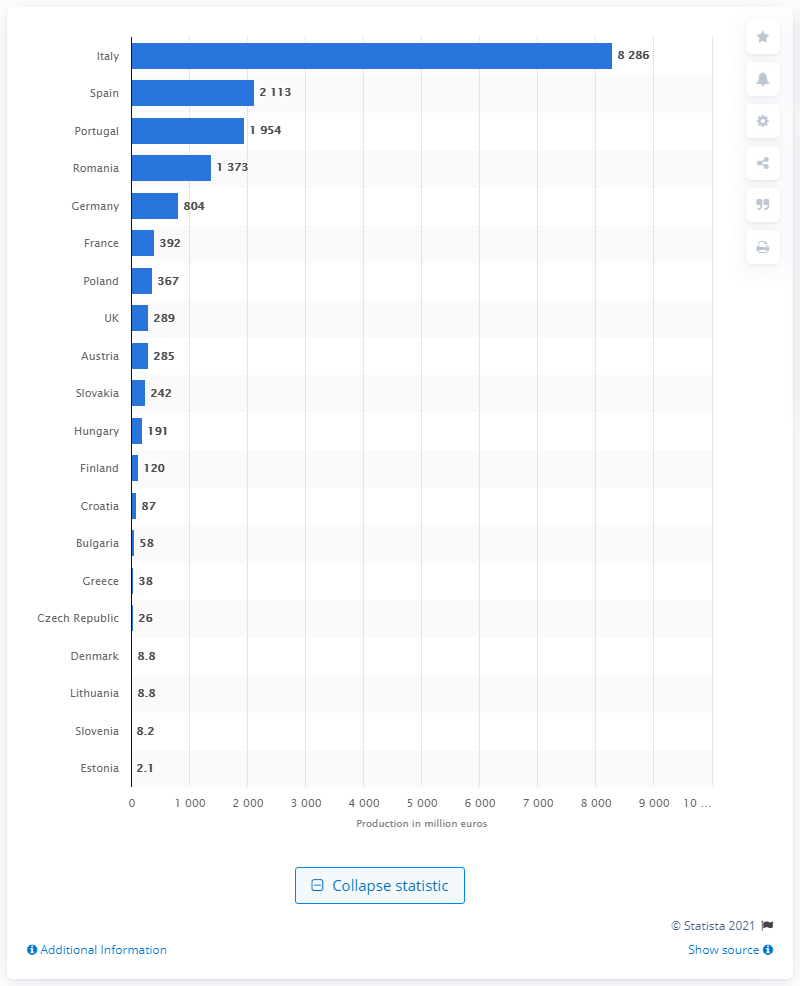Specify some key components in this picture. Italy is the country with the highest production value. In 2014, the production value of footwear in Italy was 8,286. 